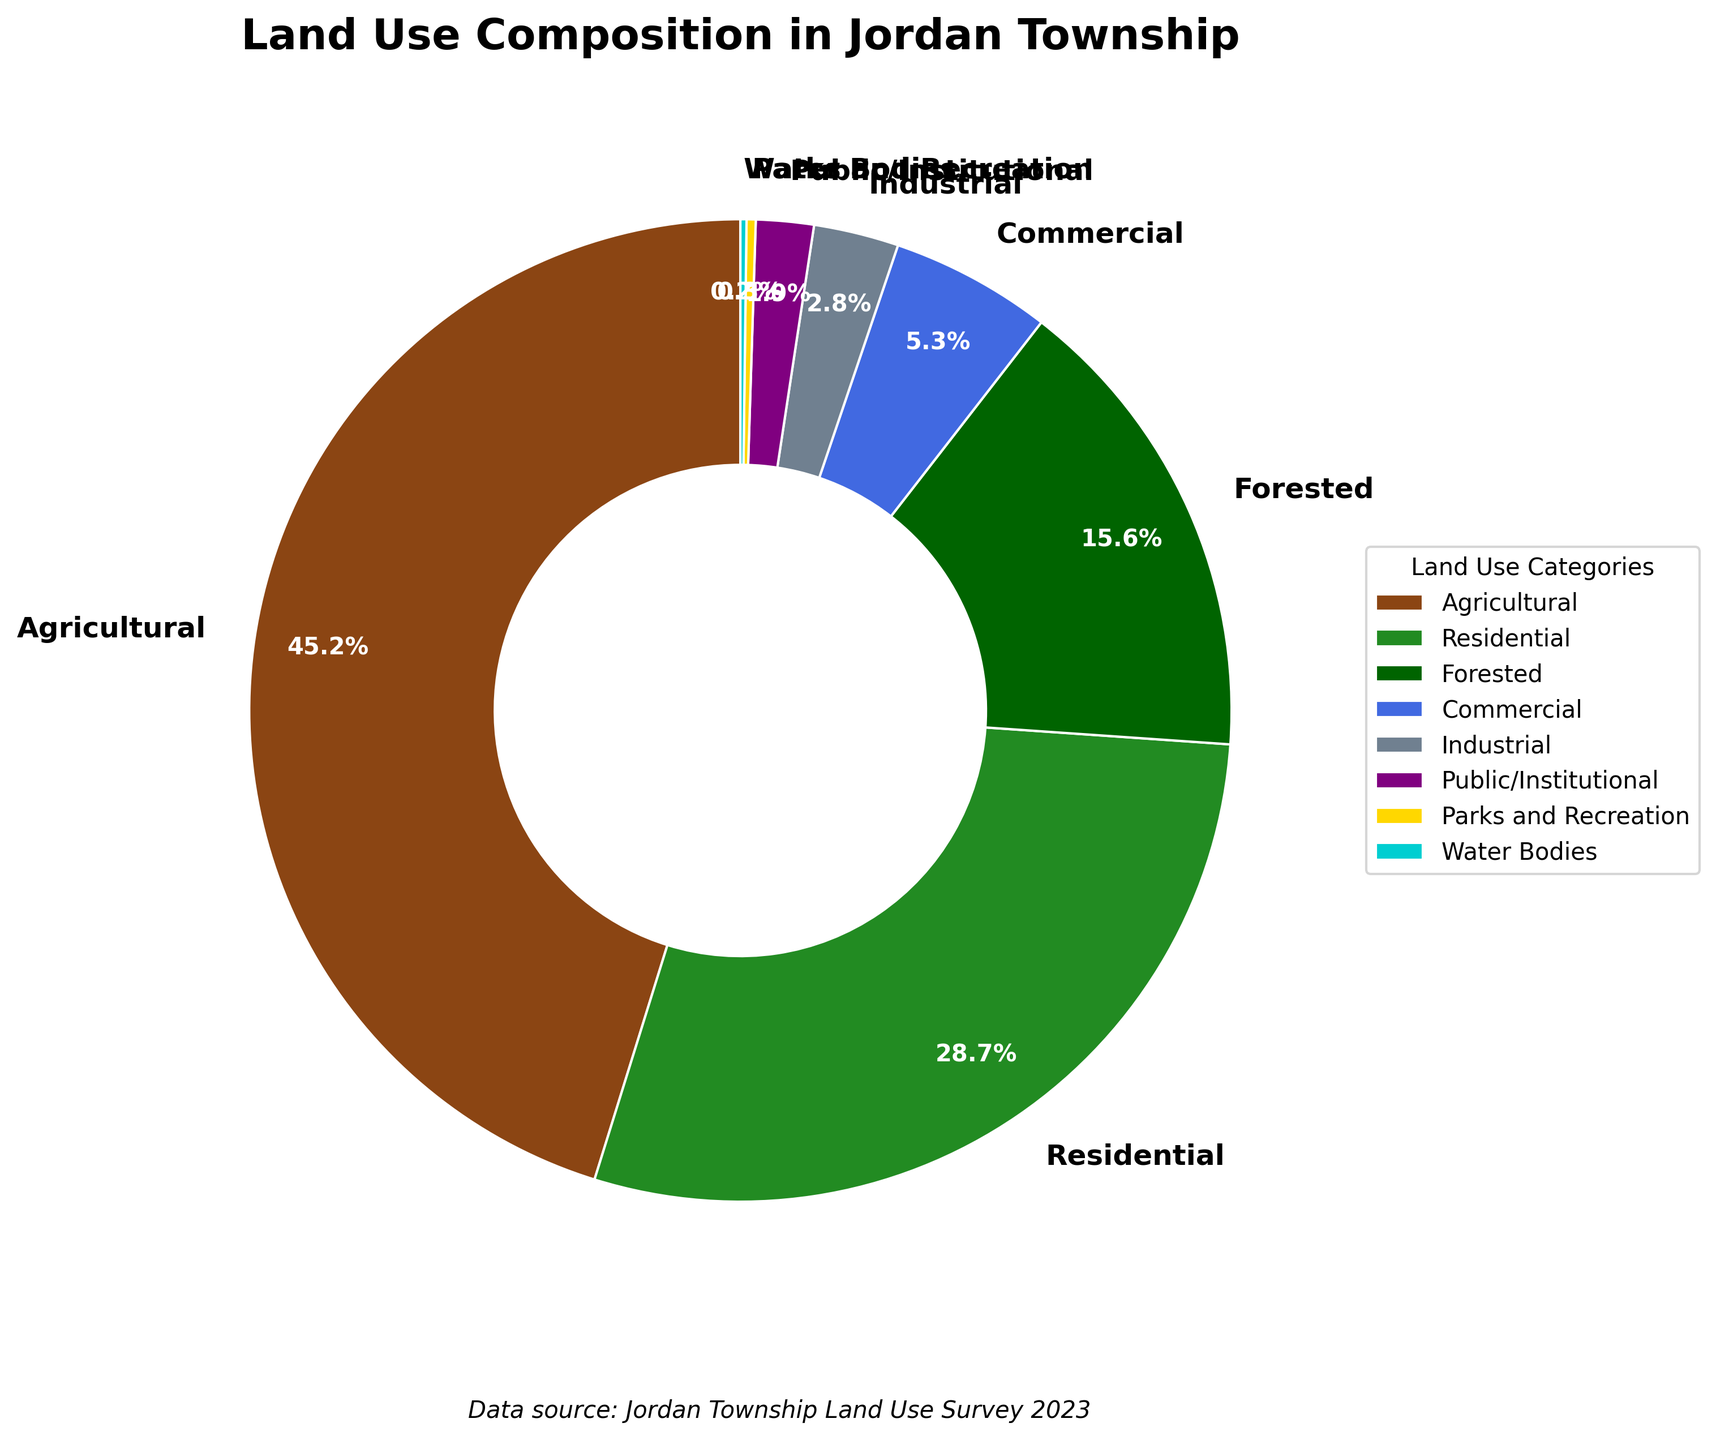What is the combined percentage of residential and commercial land use in Jordan Township? Add the percentages of Residential (28.7%) and Commercial (5.3%). So, 28.7% + 5.3% = 34%.
Answer: 34% How much more land is used for agricultural purposes compared to forested areas? Subtract the percentage of Forested (15.6%) from Agricultural (45.2%). So, 45.2% - 15.6% = 29.6%.
Answer: 29.6% What percentage of the land use is not agricultural, residential, or forested? Sum the percentages of Agricultural (45.2%), Residential (28.7%), and Forested (15.6%). The combined percentage is 45.2% + 28.7% + 15.6% = 89.5%. Subtract this from 100%. So, 100% - 89.5% = 10.5%.
Answer: 10.5% Which category has the smallest land use in Jordan Township? From the pie chart, the category with the smallest percentage is Water Bodies at 0.2%.
Answer: Water Bodies Which has a higher land use percentage in Jordan Township: residential or industrial? Compare the percentages of Residential (28.7%) and Industrial (2.8%). Residential is higher.
Answer: Residential If the percentages for parks and recreation were to double, what would it then be? Double the Parks and Recreation percentage of 0.3%. So, 0.3% * 2 = 0.6%.
Answer: 0.6% How much land use does industrial and public/institutional combined account for? Add the percentages of Industrial (2.8%) and Public/Institutional (1.9%). So, 2.8% + 1.9% = 4.7%.
Answer: 4.7% What is the difference in land use percentage between the largest and smallest categories? The largest category is Agricultural (45.2%), and the smallest is Water Bodies (0.2%). Subtract the smallest from the largest. So, 45.2% - 0.2% = 45%.
Answer: 45% Which category uses less land: parks and recreation or public/institutional? Compare the percentages of Parks and Recreation (0.3%) and Public/Institutional (1.9%). Parks and Recreation uses less land.
Answer: Parks and Recreation What land use category is represented by a bright yellow color? The color scheme assigns bright yellow to Parks and Recreation.
Answer: Parks and Recreation 